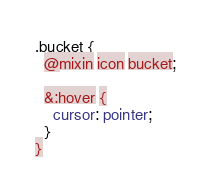<code> <loc_0><loc_0><loc_500><loc_500><_CSS_>.bucket {
  @mixin icon bucket;

  &:hover {
    cursor: pointer;
  }
}
</code> 